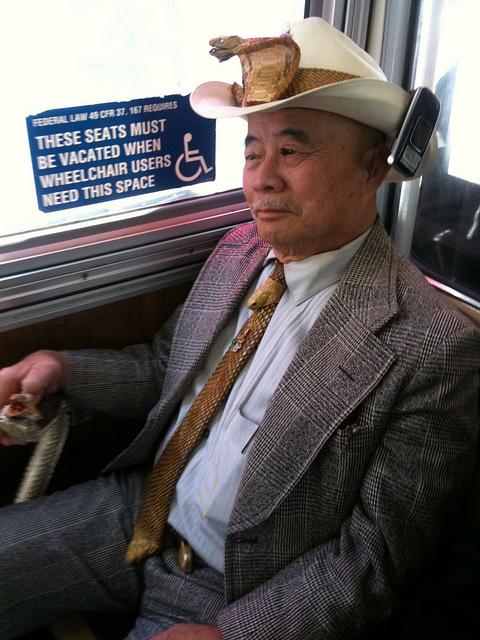What is on his hat?
Quick response, please. Snake. Is there a snake in the picture?
Give a very brief answer. No. Is this man eccentric?
Short answer required. Yes. 